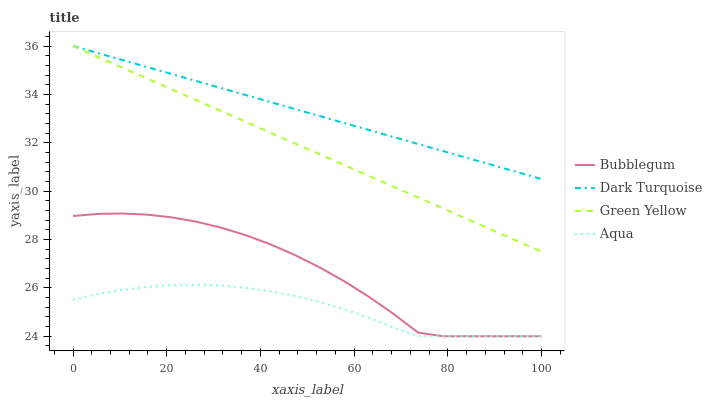Does Green Yellow have the minimum area under the curve?
Answer yes or no. No. Does Green Yellow have the maximum area under the curve?
Answer yes or no. No. Is Aqua the smoothest?
Answer yes or no. No. Is Aqua the roughest?
Answer yes or no. No. Does Green Yellow have the lowest value?
Answer yes or no. No. Does Aqua have the highest value?
Answer yes or no. No. Is Aqua less than Dark Turquoise?
Answer yes or no. Yes. Is Green Yellow greater than Bubblegum?
Answer yes or no. Yes. Does Aqua intersect Dark Turquoise?
Answer yes or no. No. 